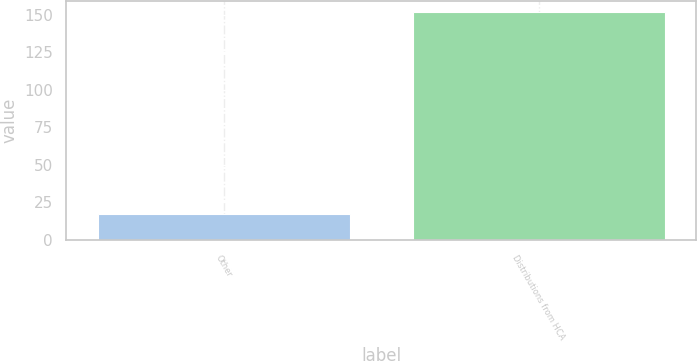Convert chart. <chart><loc_0><loc_0><loc_500><loc_500><bar_chart><fcel>Other<fcel>Distributions from HCA<nl><fcel>17<fcel>152<nl></chart> 